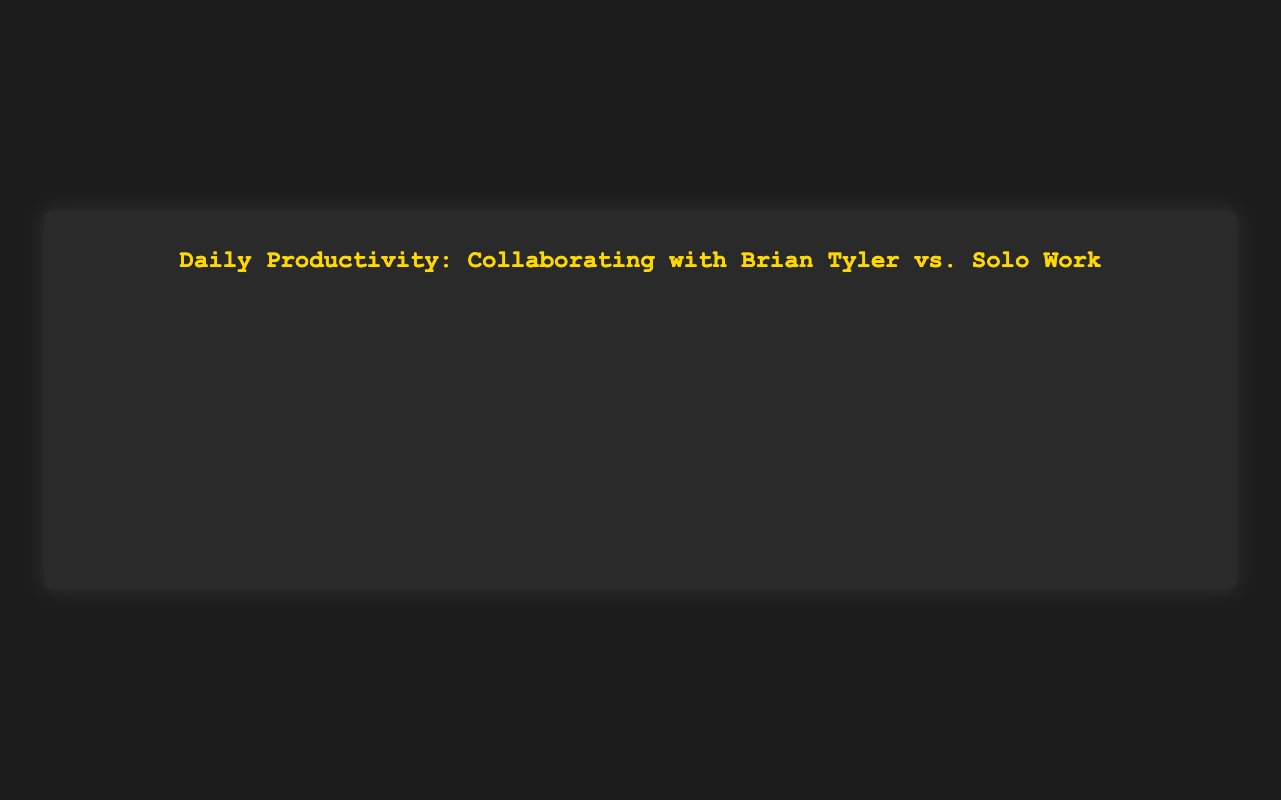What is the average productivity with Brian Tyler over the month? To find the average productivity with Brian Tyler, sum all the daily productivities and divide by the number of days. Sum = 8 + 7 + 9 + 8 + 9 + 7 + 8 + 7 + 9 + 8 + 9 + 8 + 7 + 8 + 9 + 8 + 7 + 9 + 8 + 7 + 8 + 9 + 8 + 7 + 9 + 8 + 7 + 9 + 8 + 7 + 9 = 244. Number of days = 31. Average = 244 / 31 = 7.87.
Answer: 7.87 Which day had the highest productivity without Brian Tyler? Look through the dataset for the highest productivity value without Brian Tyler. 7 is the highest value seen on October 9.
Answer: October 9 Is there a visible trend in productivity with Brian Tyler compared to without Brian Tyler? Analyzing the data, productivity is consistently higher with Brian Tyler compared to without him for each day.
Answer: Yes, consistently higher with Brian Tyler On which days did the productivity with Brian Tyler and without Brian Tyler have the same difference? Identify days where the difference between productivity with and without Brian Tyler is the same. The differences are: 3 for October 1, 2 for October 2, 4 for October 3, and checking other days verifies no matching differences except for October 2 (difference is 2) and October 7 (difference is 2). There is no day where all differences are the same.
Answer: No identical differences What are the color representations for productivity with and without Brian Tyler? The figure shows productivity with Brian Tyler labeled with a golden line and without Brian Tyler labeled with a cyan/blue line.
Answer: Golden and cyan/blue 